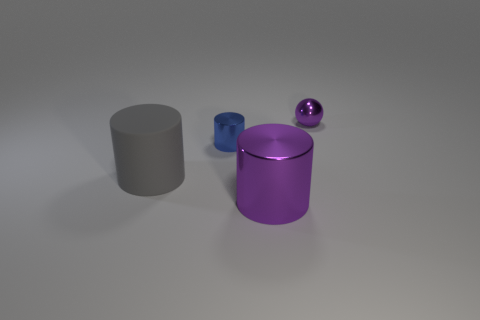Is there any other thing that is the same material as the large gray cylinder?
Your answer should be very brief. No. How many things are to the left of the big purple metal cylinder and behind the large gray rubber object?
Your answer should be compact. 1. What shape is the gray object that is the same size as the purple cylinder?
Ensure brevity in your answer.  Cylinder. There is a large cylinder that is to the right of the small shiny object left of the metal sphere; are there any large purple things behind it?
Offer a very short reply. No. Do the tiny shiny ball and the shiny cylinder on the right side of the small blue cylinder have the same color?
Provide a short and direct response. Yes. How many cylinders have the same color as the tiny ball?
Offer a terse response. 1. What is the size of the shiny thing behind the shiny cylinder behind the large metallic object?
Your answer should be very brief. Small. How many objects are either purple shiny things to the left of the tiny purple shiny thing or brown spheres?
Provide a short and direct response. 1. Are there any objects of the same size as the purple shiny ball?
Provide a short and direct response. Yes. There is a tiny shiny sphere behind the gray matte cylinder; are there any big cylinders behind it?
Your answer should be compact. No. 